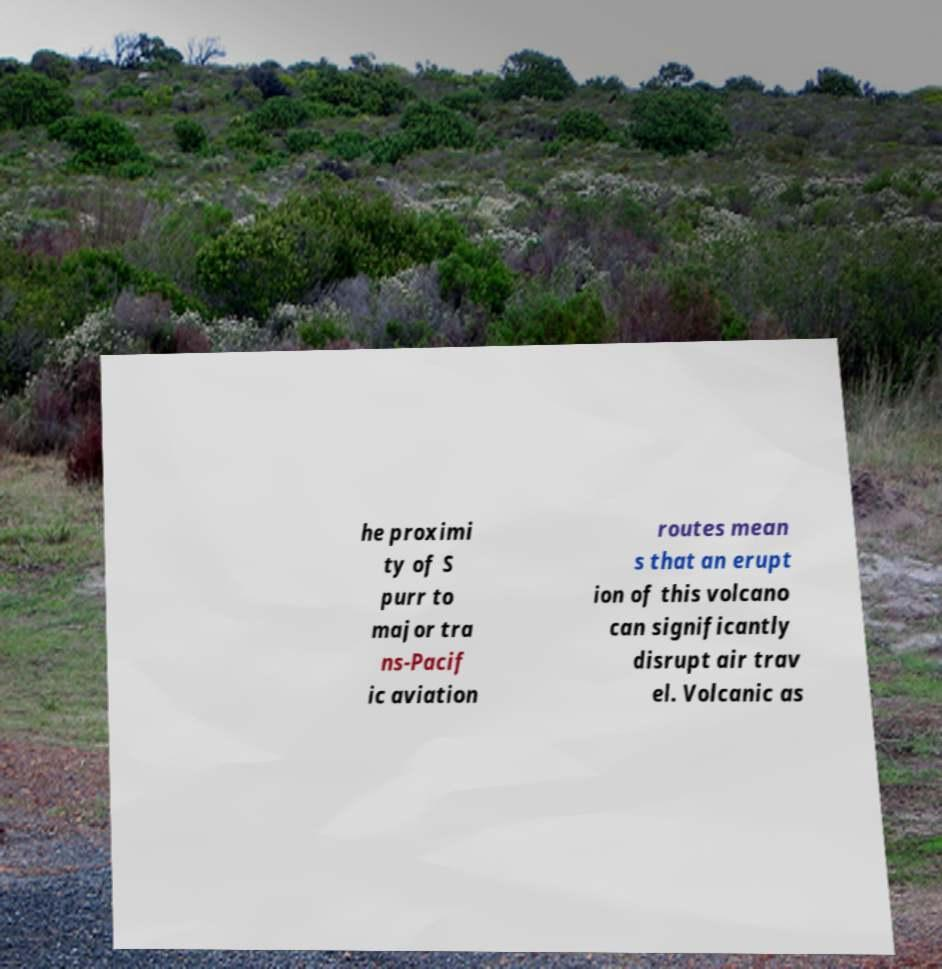Can you accurately transcribe the text from the provided image for me? he proximi ty of S purr to major tra ns-Pacif ic aviation routes mean s that an erupt ion of this volcano can significantly disrupt air trav el. Volcanic as 